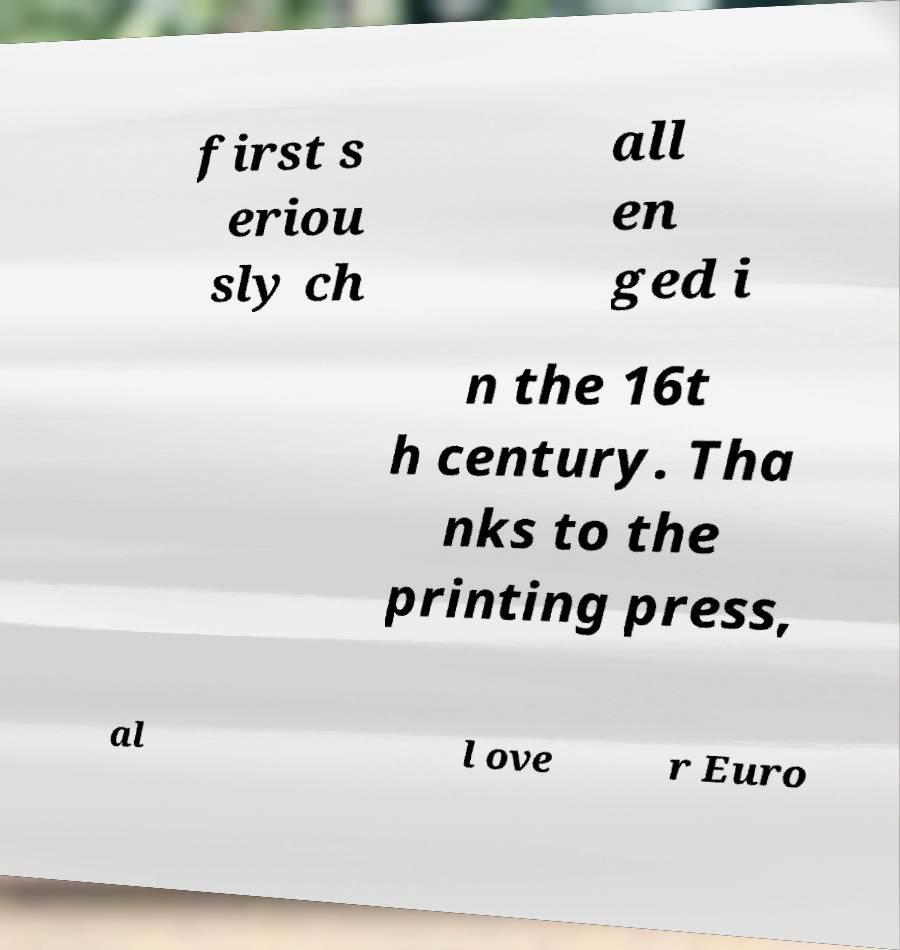I need the written content from this picture converted into text. Can you do that? first s eriou sly ch all en ged i n the 16t h century. Tha nks to the printing press, al l ove r Euro 